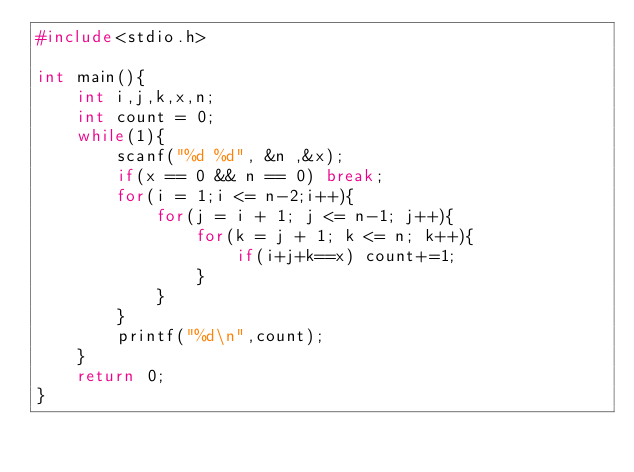Convert code to text. <code><loc_0><loc_0><loc_500><loc_500><_C_>#include<stdio.h>

int main(){
    int i,j,k,x,n;
    int count = 0;
    while(1){
        scanf("%d %d", &n ,&x);
        if(x == 0 && n == 0) break;
        for(i = 1;i <= n-2;i++){
            for(j = i + 1; j <= n-1; j++){
                for(k = j + 1; k <= n; k++){
                    if(i+j+k==x) count+=1;
                }
            }
        }
        printf("%d\n",count);
    }
    return 0;
}

</code> 